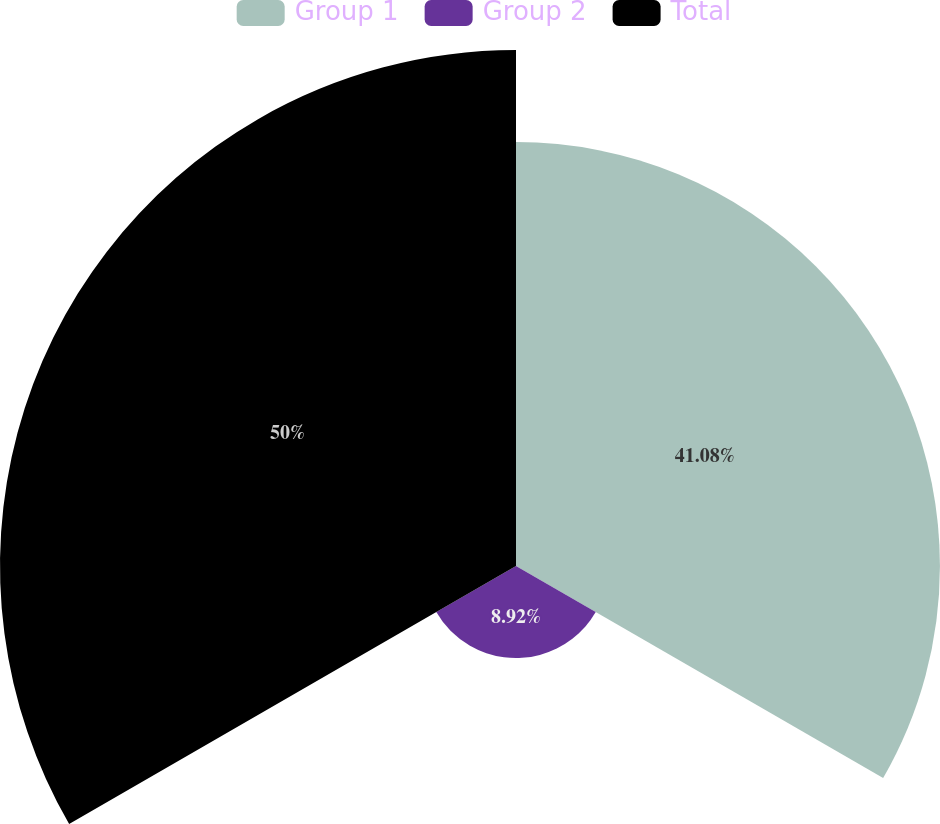Convert chart. <chart><loc_0><loc_0><loc_500><loc_500><pie_chart><fcel>Group 1<fcel>Group 2<fcel>Total<nl><fcel>41.08%<fcel>8.92%<fcel>50.0%<nl></chart> 